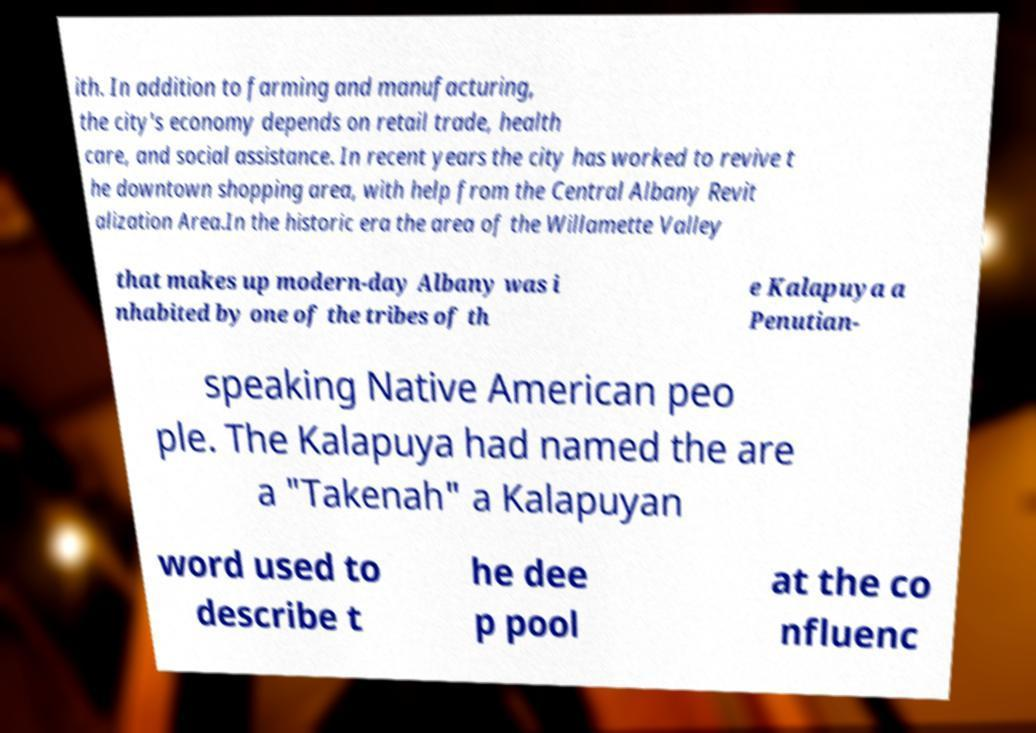Please identify and transcribe the text found in this image. ith. In addition to farming and manufacturing, the city's economy depends on retail trade, health care, and social assistance. In recent years the city has worked to revive t he downtown shopping area, with help from the Central Albany Revit alization Area.In the historic era the area of the Willamette Valley that makes up modern-day Albany was i nhabited by one of the tribes of th e Kalapuya a Penutian- speaking Native American peo ple. The Kalapuya had named the are a "Takenah" a Kalapuyan word used to describe t he dee p pool at the co nfluenc 